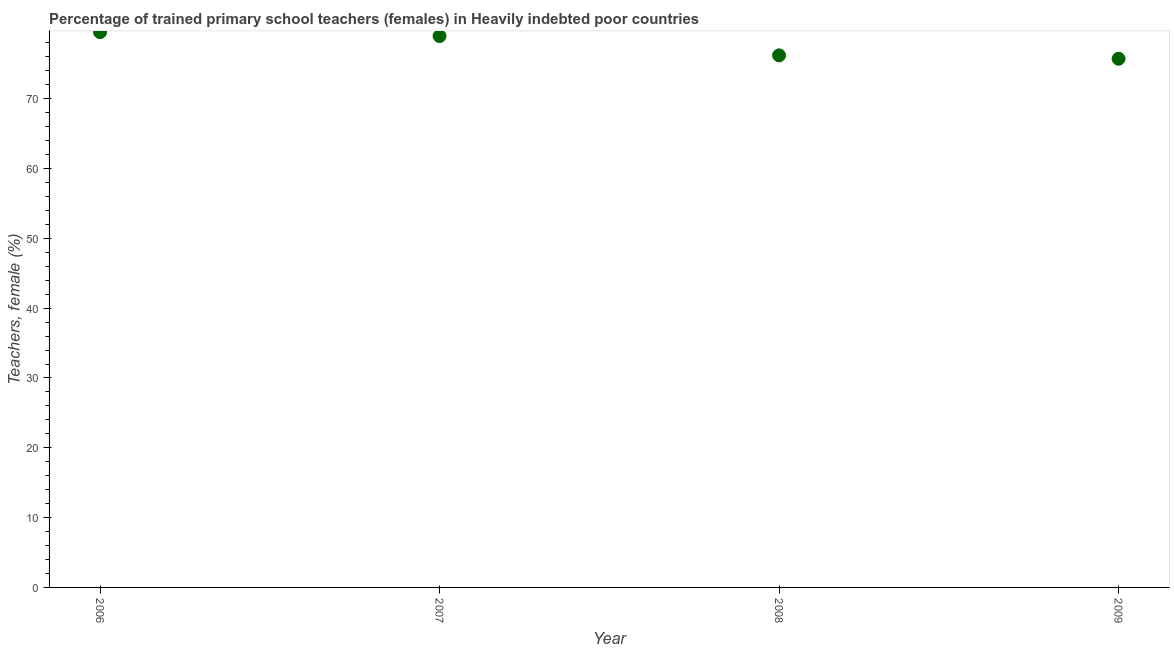What is the percentage of trained female teachers in 2007?
Provide a succinct answer. 78.97. Across all years, what is the maximum percentage of trained female teachers?
Offer a terse response. 79.53. Across all years, what is the minimum percentage of trained female teachers?
Give a very brief answer. 75.72. In which year was the percentage of trained female teachers maximum?
Provide a short and direct response. 2006. What is the sum of the percentage of trained female teachers?
Ensure brevity in your answer.  310.43. What is the difference between the percentage of trained female teachers in 2008 and 2009?
Your answer should be very brief. 0.48. What is the average percentage of trained female teachers per year?
Ensure brevity in your answer.  77.61. What is the median percentage of trained female teachers?
Give a very brief answer. 77.59. In how many years, is the percentage of trained female teachers greater than 2 %?
Your answer should be compact. 4. What is the ratio of the percentage of trained female teachers in 2007 to that in 2009?
Your response must be concise. 1.04. Is the percentage of trained female teachers in 2008 less than that in 2009?
Ensure brevity in your answer.  No. Is the difference between the percentage of trained female teachers in 2006 and 2009 greater than the difference between any two years?
Make the answer very short. Yes. What is the difference between the highest and the second highest percentage of trained female teachers?
Offer a very short reply. 0.56. What is the difference between the highest and the lowest percentage of trained female teachers?
Keep it short and to the point. 3.81. Does the percentage of trained female teachers monotonically increase over the years?
Give a very brief answer. No. How many dotlines are there?
Offer a very short reply. 1. How many years are there in the graph?
Ensure brevity in your answer.  4. Are the values on the major ticks of Y-axis written in scientific E-notation?
Your answer should be compact. No. Does the graph contain any zero values?
Ensure brevity in your answer.  No. What is the title of the graph?
Provide a succinct answer. Percentage of trained primary school teachers (females) in Heavily indebted poor countries. What is the label or title of the Y-axis?
Provide a short and direct response. Teachers, female (%). What is the Teachers, female (%) in 2006?
Offer a terse response. 79.53. What is the Teachers, female (%) in 2007?
Ensure brevity in your answer.  78.97. What is the Teachers, female (%) in 2008?
Keep it short and to the point. 76.21. What is the Teachers, female (%) in 2009?
Ensure brevity in your answer.  75.72. What is the difference between the Teachers, female (%) in 2006 and 2007?
Your answer should be very brief. 0.56. What is the difference between the Teachers, female (%) in 2006 and 2008?
Offer a terse response. 3.33. What is the difference between the Teachers, female (%) in 2006 and 2009?
Your answer should be compact. 3.81. What is the difference between the Teachers, female (%) in 2007 and 2008?
Give a very brief answer. 2.76. What is the difference between the Teachers, female (%) in 2007 and 2009?
Give a very brief answer. 3.25. What is the difference between the Teachers, female (%) in 2008 and 2009?
Your answer should be compact. 0.48. What is the ratio of the Teachers, female (%) in 2006 to that in 2007?
Your response must be concise. 1.01. What is the ratio of the Teachers, female (%) in 2006 to that in 2008?
Make the answer very short. 1.04. What is the ratio of the Teachers, female (%) in 2006 to that in 2009?
Provide a short and direct response. 1.05. What is the ratio of the Teachers, female (%) in 2007 to that in 2008?
Your answer should be compact. 1.04. What is the ratio of the Teachers, female (%) in 2007 to that in 2009?
Your answer should be compact. 1.04. What is the ratio of the Teachers, female (%) in 2008 to that in 2009?
Provide a succinct answer. 1.01. 